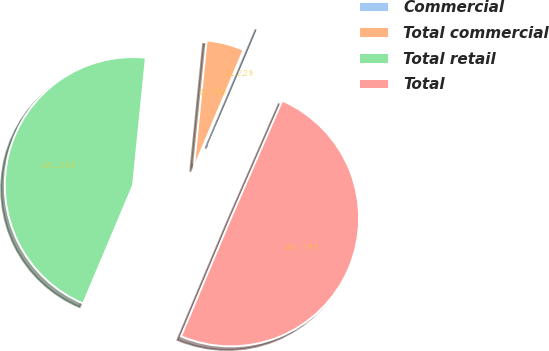Convert chart to OTSL. <chart><loc_0><loc_0><loc_500><loc_500><pie_chart><fcel>Commercial<fcel>Total commercial<fcel>Total retail<fcel>Total<nl><fcel>0.22%<fcel>4.75%<fcel>45.25%<fcel>49.78%<nl></chart> 